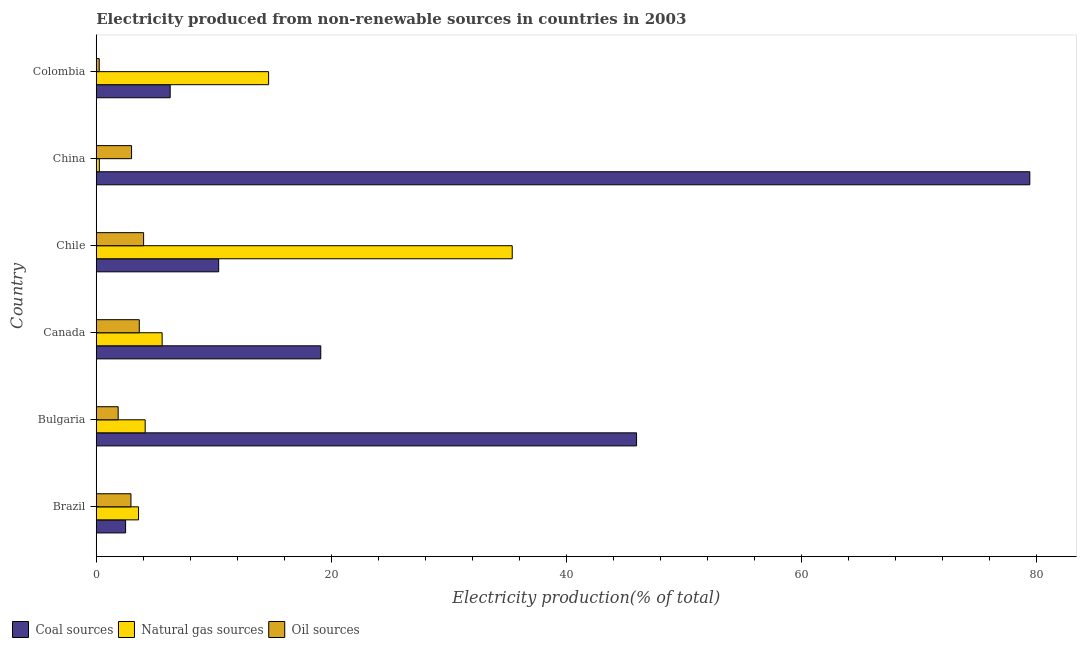How many groups of bars are there?
Offer a terse response. 6. Are the number of bars per tick equal to the number of legend labels?
Offer a terse response. Yes. What is the percentage of electricity produced by coal in Brazil?
Make the answer very short. 2.5. Across all countries, what is the maximum percentage of electricity produced by coal?
Give a very brief answer. 79.44. Across all countries, what is the minimum percentage of electricity produced by coal?
Your response must be concise. 2.5. What is the total percentage of electricity produced by natural gas in the graph?
Offer a terse response. 63.69. What is the difference between the percentage of electricity produced by oil sources in China and that in Colombia?
Offer a very short reply. 2.75. What is the difference between the percentage of electricity produced by natural gas in Bulgaria and the percentage of electricity produced by oil sources in Brazil?
Offer a terse response. 1.21. What is the average percentage of electricity produced by oil sources per country?
Offer a terse response. 2.63. What is the difference between the percentage of electricity produced by natural gas and percentage of electricity produced by coal in Brazil?
Give a very brief answer. 1.1. What is the ratio of the percentage of electricity produced by oil sources in Brazil to that in Canada?
Give a very brief answer. 0.81. Is the difference between the percentage of electricity produced by coal in Canada and Colombia greater than the difference between the percentage of electricity produced by natural gas in Canada and Colombia?
Your response must be concise. Yes. What is the difference between the highest and the second highest percentage of electricity produced by natural gas?
Provide a short and direct response. 20.73. What is the difference between the highest and the lowest percentage of electricity produced by oil sources?
Offer a very short reply. 3.78. In how many countries, is the percentage of electricity produced by oil sources greater than the average percentage of electricity produced by oil sources taken over all countries?
Provide a short and direct response. 4. What does the 1st bar from the top in Chile represents?
Your response must be concise. Oil sources. What does the 1st bar from the bottom in Canada represents?
Give a very brief answer. Coal sources. Is it the case that in every country, the sum of the percentage of electricity produced by coal and percentage of electricity produced by natural gas is greater than the percentage of electricity produced by oil sources?
Provide a succinct answer. Yes. Are all the bars in the graph horizontal?
Ensure brevity in your answer.  Yes. How many countries are there in the graph?
Make the answer very short. 6. Are the values on the major ticks of X-axis written in scientific E-notation?
Your response must be concise. No. Does the graph contain grids?
Provide a succinct answer. No. Where does the legend appear in the graph?
Your answer should be compact. Bottom left. What is the title of the graph?
Provide a succinct answer. Electricity produced from non-renewable sources in countries in 2003. What is the Electricity production(% of total) in Coal sources in Brazil?
Your answer should be compact. 2.5. What is the Electricity production(% of total) in Natural gas sources in Brazil?
Keep it short and to the point. 3.6. What is the Electricity production(% of total) of Oil sources in Brazil?
Ensure brevity in your answer.  2.95. What is the Electricity production(% of total) of Coal sources in Bulgaria?
Ensure brevity in your answer.  45.98. What is the Electricity production(% of total) in Natural gas sources in Bulgaria?
Offer a very short reply. 4.16. What is the Electricity production(% of total) of Oil sources in Bulgaria?
Make the answer very short. 1.86. What is the Electricity production(% of total) of Coal sources in Canada?
Provide a succinct answer. 19.11. What is the Electricity production(% of total) in Natural gas sources in Canada?
Provide a short and direct response. 5.61. What is the Electricity production(% of total) in Oil sources in Canada?
Ensure brevity in your answer.  3.66. What is the Electricity production(% of total) of Coal sources in Chile?
Offer a very short reply. 10.42. What is the Electricity production(% of total) of Natural gas sources in Chile?
Your response must be concise. 35.4. What is the Electricity production(% of total) in Oil sources in Chile?
Offer a terse response. 4.03. What is the Electricity production(% of total) in Coal sources in China?
Keep it short and to the point. 79.44. What is the Electricity production(% of total) of Natural gas sources in China?
Keep it short and to the point. 0.26. What is the Electricity production(% of total) of Oil sources in China?
Keep it short and to the point. 3. What is the Electricity production(% of total) in Coal sources in Colombia?
Provide a short and direct response. 6.29. What is the Electricity production(% of total) of Natural gas sources in Colombia?
Ensure brevity in your answer.  14.67. What is the Electricity production(% of total) of Oil sources in Colombia?
Make the answer very short. 0.25. Across all countries, what is the maximum Electricity production(% of total) in Coal sources?
Make the answer very short. 79.44. Across all countries, what is the maximum Electricity production(% of total) in Natural gas sources?
Give a very brief answer. 35.4. Across all countries, what is the maximum Electricity production(% of total) of Oil sources?
Keep it short and to the point. 4.03. Across all countries, what is the minimum Electricity production(% of total) in Coal sources?
Give a very brief answer. 2.5. Across all countries, what is the minimum Electricity production(% of total) in Natural gas sources?
Your response must be concise. 0.26. Across all countries, what is the minimum Electricity production(% of total) of Oil sources?
Keep it short and to the point. 0.25. What is the total Electricity production(% of total) of Coal sources in the graph?
Your answer should be very brief. 163.73. What is the total Electricity production(% of total) in Natural gas sources in the graph?
Offer a very short reply. 63.69. What is the total Electricity production(% of total) of Oil sources in the graph?
Give a very brief answer. 15.76. What is the difference between the Electricity production(% of total) of Coal sources in Brazil and that in Bulgaria?
Your response must be concise. -43.48. What is the difference between the Electricity production(% of total) of Natural gas sources in Brazil and that in Bulgaria?
Keep it short and to the point. -0.56. What is the difference between the Electricity production(% of total) in Oil sources in Brazil and that in Bulgaria?
Your answer should be very brief. 1.09. What is the difference between the Electricity production(% of total) in Coal sources in Brazil and that in Canada?
Your response must be concise. -16.61. What is the difference between the Electricity production(% of total) in Natural gas sources in Brazil and that in Canada?
Your answer should be very brief. -2.01. What is the difference between the Electricity production(% of total) of Oil sources in Brazil and that in Canada?
Provide a short and direct response. -0.71. What is the difference between the Electricity production(% of total) in Coal sources in Brazil and that in Chile?
Ensure brevity in your answer.  -7.92. What is the difference between the Electricity production(% of total) of Natural gas sources in Brazil and that in Chile?
Give a very brief answer. -31.8. What is the difference between the Electricity production(% of total) of Oil sources in Brazil and that in Chile?
Provide a short and direct response. -1.08. What is the difference between the Electricity production(% of total) of Coal sources in Brazil and that in China?
Provide a succinct answer. -76.95. What is the difference between the Electricity production(% of total) of Natural gas sources in Brazil and that in China?
Provide a short and direct response. 3.34. What is the difference between the Electricity production(% of total) in Oil sources in Brazil and that in China?
Offer a terse response. -0.05. What is the difference between the Electricity production(% of total) of Coal sources in Brazil and that in Colombia?
Provide a short and direct response. -3.8. What is the difference between the Electricity production(% of total) of Natural gas sources in Brazil and that in Colombia?
Give a very brief answer. -11.07. What is the difference between the Electricity production(% of total) in Oil sources in Brazil and that in Colombia?
Offer a terse response. 2.7. What is the difference between the Electricity production(% of total) in Coal sources in Bulgaria and that in Canada?
Offer a terse response. 26.87. What is the difference between the Electricity production(% of total) of Natural gas sources in Bulgaria and that in Canada?
Provide a succinct answer. -1.44. What is the difference between the Electricity production(% of total) of Oil sources in Bulgaria and that in Canada?
Ensure brevity in your answer.  -1.8. What is the difference between the Electricity production(% of total) in Coal sources in Bulgaria and that in Chile?
Offer a terse response. 35.56. What is the difference between the Electricity production(% of total) in Natural gas sources in Bulgaria and that in Chile?
Your answer should be very brief. -31.23. What is the difference between the Electricity production(% of total) in Oil sources in Bulgaria and that in Chile?
Offer a terse response. -2.17. What is the difference between the Electricity production(% of total) in Coal sources in Bulgaria and that in China?
Ensure brevity in your answer.  -33.46. What is the difference between the Electricity production(% of total) in Natural gas sources in Bulgaria and that in China?
Make the answer very short. 3.9. What is the difference between the Electricity production(% of total) in Oil sources in Bulgaria and that in China?
Ensure brevity in your answer.  -1.14. What is the difference between the Electricity production(% of total) of Coal sources in Bulgaria and that in Colombia?
Make the answer very short. 39.69. What is the difference between the Electricity production(% of total) of Natural gas sources in Bulgaria and that in Colombia?
Provide a succinct answer. -10.5. What is the difference between the Electricity production(% of total) in Oil sources in Bulgaria and that in Colombia?
Offer a terse response. 1.61. What is the difference between the Electricity production(% of total) in Coal sources in Canada and that in Chile?
Provide a succinct answer. 8.69. What is the difference between the Electricity production(% of total) in Natural gas sources in Canada and that in Chile?
Your answer should be very brief. -29.79. What is the difference between the Electricity production(% of total) of Oil sources in Canada and that in Chile?
Keep it short and to the point. -0.37. What is the difference between the Electricity production(% of total) in Coal sources in Canada and that in China?
Keep it short and to the point. -60.34. What is the difference between the Electricity production(% of total) in Natural gas sources in Canada and that in China?
Make the answer very short. 5.34. What is the difference between the Electricity production(% of total) in Oil sources in Canada and that in China?
Your answer should be very brief. 0.66. What is the difference between the Electricity production(% of total) of Coal sources in Canada and that in Colombia?
Provide a short and direct response. 12.81. What is the difference between the Electricity production(% of total) in Natural gas sources in Canada and that in Colombia?
Make the answer very short. -9.06. What is the difference between the Electricity production(% of total) of Oil sources in Canada and that in Colombia?
Keep it short and to the point. 3.41. What is the difference between the Electricity production(% of total) of Coal sources in Chile and that in China?
Offer a very short reply. -69.03. What is the difference between the Electricity production(% of total) in Natural gas sources in Chile and that in China?
Offer a very short reply. 35.13. What is the difference between the Electricity production(% of total) in Oil sources in Chile and that in China?
Your response must be concise. 1.03. What is the difference between the Electricity production(% of total) of Coal sources in Chile and that in Colombia?
Provide a short and direct response. 4.13. What is the difference between the Electricity production(% of total) in Natural gas sources in Chile and that in Colombia?
Ensure brevity in your answer.  20.73. What is the difference between the Electricity production(% of total) in Oil sources in Chile and that in Colombia?
Offer a terse response. 3.78. What is the difference between the Electricity production(% of total) of Coal sources in China and that in Colombia?
Ensure brevity in your answer.  73.15. What is the difference between the Electricity production(% of total) in Natural gas sources in China and that in Colombia?
Your answer should be very brief. -14.4. What is the difference between the Electricity production(% of total) in Oil sources in China and that in Colombia?
Your answer should be very brief. 2.75. What is the difference between the Electricity production(% of total) of Coal sources in Brazil and the Electricity production(% of total) of Natural gas sources in Bulgaria?
Offer a very short reply. -1.67. What is the difference between the Electricity production(% of total) of Coal sources in Brazil and the Electricity production(% of total) of Oil sources in Bulgaria?
Keep it short and to the point. 0.63. What is the difference between the Electricity production(% of total) in Natural gas sources in Brazil and the Electricity production(% of total) in Oil sources in Bulgaria?
Provide a short and direct response. 1.73. What is the difference between the Electricity production(% of total) in Coal sources in Brazil and the Electricity production(% of total) in Natural gas sources in Canada?
Ensure brevity in your answer.  -3.11. What is the difference between the Electricity production(% of total) of Coal sources in Brazil and the Electricity production(% of total) of Oil sources in Canada?
Offer a very short reply. -1.17. What is the difference between the Electricity production(% of total) in Natural gas sources in Brazil and the Electricity production(% of total) in Oil sources in Canada?
Your response must be concise. -0.06. What is the difference between the Electricity production(% of total) in Coal sources in Brazil and the Electricity production(% of total) in Natural gas sources in Chile?
Provide a succinct answer. -32.9. What is the difference between the Electricity production(% of total) of Coal sources in Brazil and the Electricity production(% of total) of Oil sources in Chile?
Your response must be concise. -1.53. What is the difference between the Electricity production(% of total) in Natural gas sources in Brazil and the Electricity production(% of total) in Oil sources in Chile?
Give a very brief answer. -0.43. What is the difference between the Electricity production(% of total) in Coal sources in Brazil and the Electricity production(% of total) in Natural gas sources in China?
Provide a succinct answer. 2.23. What is the difference between the Electricity production(% of total) of Coal sources in Brazil and the Electricity production(% of total) of Oil sources in China?
Provide a succinct answer. -0.51. What is the difference between the Electricity production(% of total) in Natural gas sources in Brazil and the Electricity production(% of total) in Oil sources in China?
Keep it short and to the point. 0.59. What is the difference between the Electricity production(% of total) in Coal sources in Brazil and the Electricity production(% of total) in Natural gas sources in Colombia?
Make the answer very short. -12.17. What is the difference between the Electricity production(% of total) in Coal sources in Brazil and the Electricity production(% of total) in Oil sources in Colombia?
Your response must be concise. 2.24. What is the difference between the Electricity production(% of total) of Natural gas sources in Brazil and the Electricity production(% of total) of Oil sources in Colombia?
Offer a terse response. 3.34. What is the difference between the Electricity production(% of total) in Coal sources in Bulgaria and the Electricity production(% of total) in Natural gas sources in Canada?
Your answer should be very brief. 40.37. What is the difference between the Electricity production(% of total) in Coal sources in Bulgaria and the Electricity production(% of total) in Oil sources in Canada?
Your answer should be compact. 42.32. What is the difference between the Electricity production(% of total) in Natural gas sources in Bulgaria and the Electricity production(% of total) in Oil sources in Canada?
Give a very brief answer. 0.5. What is the difference between the Electricity production(% of total) of Coal sources in Bulgaria and the Electricity production(% of total) of Natural gas sources in Chile?
Offer a terse response. 10.58. What is the difference between the Electricity production(% of total) in Coal sources in Bulgaria and the Electricity production(% of total) in Oil sources in Chile?
Your answer should be compact. 41.95. What is the difference between the Electricity production(% of total) of Natural gas sources in Bulgaria and the Electricity production(% of total) of Oil sources in Chile?
Your answer should be compact. 0.13. What is the difference between the Electricity production(% of total) of Coal sources in Bulgaria and the Electricity production(% of total) of Natural gas sources in China?
Ensure brevity in your answer.  45.72. What is the difference between the Electricity production(% of total) of Coal sources in Bulgaria and the Electricity production(% of total) of Oil sources in China?
Your response must be concise. 42.98. What is the difference between the Electricity production(% of total) in Natural gas sources in Bulgaria and the Electricity production(% of total) in Oil sources in China?
Give a very brief answer. 1.16. What is the difference between the Electricity production(% of total) in Coal sources in Bulgaria and the Electricity production(% of total) in Natural gas sources in Colombia?
Make the answer very short. 31.31. What is the difference between the Electricity production(% of total) in Coal sources in Bulgaria and the Electricity production(% of total) in Oil sources in Colombia?
Keep it short and to the point. 45.73. What is the difference between the Electricity production(% of total) in Natural gas sources in Bulgaria and the Electricity production(% of total) in Oil sources in Colombia?
Provide a succinct answer. 3.91. What is the difference between the Electricity production(% of total) of Coal sources in Canada and the Electricity production(% of total) of Natural gas sources in Chile?
Make the answer very short. -16.29. What is the difference between the Electricity production(% of total) of Coal sources in Canada and the Electricity production(% of total) of Oil sources in Chile?
Provide a short and direct response. 15.08. What is the difference between the Electricity production(% of total) of Natural gas sources in Canada and the Electricity production(% of total) of Oil sources in Chile?
Offer a very short reply. 1.58. What is the difference between the Electricity production(% of total) of Coal sources in Canada and the Electricity production(% of total) of Natural gas sources in China?
Provide a succinct answer. 18.84. What is the difference between the Electricity production(% of total) in Coal sources in Canada and the Electricity production(% of total) in Oil sources in China?
Give a very brief answer. 16.1. What is the difference between the Electricity production(% of total) in Natural gas sources in Canada and the Electricity production(% of total) in Oil sources in China?
Your answer should be compact. 2.6. What is the difference between the Electricity production(% of total) in Coal sources in Canada and the Electricity production(% of total) in Natural gas sources in Colombia?
Provide a succinct answer. 4.44. What is the difference between the Electricity production(% of total) of Coal sources in Canada and the Electricity production(% of total) of Oil sources in Colombia?
Your answer should be compact. 18.85. What is the difference between the Electricity production(% of total) of Natural gas sources in Canada and the Electricity production(% of total) of Oil sources in Colombia?
Ensure brevity in your answer.  5.35. What is the difference between the Electricity production(% of total) of Coal sources in Chile and the Electricity production(% of total) of Natural gas sources in China?
Keep it short and to the point. 10.15. What is the difference between the Electricity production(% of total) of Coal sources in Chile and the Electricity production(% of total) of Oil sources in China?
Keep it short and to the point. 7.41. What is the difference between the Electricity production(% of total) of Natural gas sources in Chile and the Electricity production(% of total) of Oil sources in China?
Your answer should be compact. 32.39. What is the difference between the Electricity production(% of total) in Coal sources in Chile and the Electricity production(% of total) in Natural gas sources in Colombia?
Offer a terse response. -4.25. What is the difference between the Electricity production(% of total) of Coal sources in Chile and the Electricity production(% of total) of Oil sources in Colombia?
Give a very brief answer. 10.16. What is the difference between the Electricity production(% of total) in Natural gas sources in Chile and the Electricity production(% of total) in Oil sources in Colombia?
Provide a short and direct response. 35.14. What is the difference between the Electricity production(% of total) of Coal sources in China and the Electricity production(% of total) of Natural gas sources in Colombia?
Give a very brief answer. 64.78. What is the difference between the Electricity production(% of total) in Coal sources in China and the Electricity production(% of total) in Oil sources in Colombia?
Make the answer very short. 79.19. What is the difference between the Electricity production(% of total) of Natural gas sources in China and the Electricity production(% of total) of Oil sources in Colombia?
Make the answer very short. 0.01. What is the average Electricity production(% of total) in Coal sources per country?
Give a very brief answer. 27.29. What is the average Electricity production(% of total) of Natural gas sources per country?
Keep it short and to the point. 10.62. What is the average Electricity production(% of total) of Oil sources per country?
Ensure brevity in your answer.  2.63. What is the difference between the Electricity production(% of total) in Coal sources and Electricity production(% of total) in Natural gas sources in Brazil?
Your answer should be very brief. -1.1. What is the difference between the Electricity production(% of total) of Coal sources and Electricity production(% of total) of Oil sources in Brazil?
Offer a very short reply. -0.46. What is the difference between the Electricity production(% of total) of Natural gas sources and Electricity production(% of total) of Oil sources in Brazil?
Offer a terse response. 0.65. What is the difference between the Electricity production(% of total) of Coal sources and Electricity production(% of total) of Natural gas sources in Bulgaria?
Your answer should be very brief. 41.82. What is the difference between the Electricity production(% of total) in Coal sources and Electricity production(% of total) in Oil sources in Bulgaria?
Give a very brief answer. 44.12. What is the difference between the Electricity production(% of total) in Natural gas sources and Electricity production(% of total) in Oil sources in Bulgaria?
Keep it short and to the point. 2.3. What is the difference between the Electricity production(% of total) of Coal sources and Electricity production(% of total) of Natural gas sources in Canada?
Your answer should be very brief. 13.5. What is the difference between the Electricity production(% of total) in Coal sources and Electricity production(% of total) in Oil sources in Canada?
Give a very brief answer. 15.44. What is the difference between the Electricity production(% of total) in Natural gas sources and Electricity production(% of total) in Oil sources in Canada?
Your answer should be very brief. 1.95. What is the difference between the Electricity production(% of total) in Coal sources and Electricity production(% of total) in Natural gas sources in Chile?
Your response must be concise. -24.98. What is the difference between the Electricity production(% of total) in Coal sources and Electricity production(% of total) in Oil sources in Chile?
Provide a succinct answer. 6.39. What is the difference between the Electricity production(% of total) in Natural gas sources and Electricity production(% of total) in Oil sources in Chile?
Your answer should be very brief. 31.37. What is the difference between the Electricity production(% of total) in Coal sources and Electricity production(% of total) in Natural gas sources in China?
Offer a terse response. 79.18. What is the difference between the Electricity production(% of total) in Coal sources and Electricity production(% of total) in Oil sources in China?
Make the answer very short. 76.44. What is the difference between the Electricity production(% of total) of Natural gas sources and Electricity production(% of total) of Oil sources in China?
Ensure brevity in your answer.  -2.74. What is the difference between the Electricity production(% of total) of Coal sources and Electricity production(% of total) of Natural gas sources in Colombia?
Offer a very short reply. -8.38. What is the difference between the Electricity production(% of total) of Coal sources and Electricity production(% of total) of Oil sources in Colombia?
Provide a short and direct response. 6.04. What is the difference between the Electricity production(% of total) in Natural gas sources and Electricity production(% of total) in Oil sources in Colombia?
Give a very brief answer. 14.41. What is the ratio of the Electricity production(% of total) in Coal sources in Brazil to that in Bulgaria?
Offer a terse response. 0.05. What is the ratio of the Electricity production(% of total) of Natural gas sources in Brazil to that in Bulgaria?
Your response must be concise. 0.86. What is the ratio of the Electricity production(% of total) in Oil sources in Brazil to that in Bulgaria?
Offer a very short reply. 1.58. What is the ratio of the Electricity production(% of total) in Coal sources in Brazil to that in Canada?
Provide a short and direct response. 0.13. What is the ratio of the Electricity production(% of total) in Natural gas sources in Brazil to that in Canada?
Make the answer very short. 0.64. What is the ratio of the Electricity production(% of total) in Oil sources in Brazil to that in Canada?
Your answer should be compact. 0.81. What is the ratio of the Electricity production(% of total) in Coal sources in Brazil to that in Chile?
Your answer should be very brief. 0.24. What is the ratio of the Electricity production(% of total) in Natural gas sources in Brazil to that in Chile?
Your answer should be compact. 0.1. What is the ratio of the Electricity production(% of total) in Oil sources in Brazil to that in Chile?
Provide a succinct answer. 0.73. What is the ratio of the Electricity production(% of total) in Coal sources in Brazil to that in China?
Offer a terse response. 0.03. What is the ratio of the Electricity production(% of total) of Natural gas sources in Brazil to that in China?
Your answer should be very brief. 13.72. What is the ratio of the Electricity production(% of total) in Oil sources in Brazil to that in China?
Your answer should be very brief. 0.98. What is the ratio of the Electricity production(% of total) of Coal sources in Brazil to that in Colombia?
Ensure brevity in your answer.  0.4. What is the ratio of the Electricity production(% of total) in Natural gas sources in Brazil to that in Colombia?
Make the answer very short. 0.25. What is the ratio of the Electricity production(% of total) of Oil sources in Brazil to that in Colombia?
Your response must be concise. 11.64. What is the ratio of the Electricity production(% of total) of Coal sources in Bulgaria to that in Canada?
Keep it short and to the point. 2.41. What is the ratio of the Electricity production(% of total) of Natural gas sources in Bulgaria to that in Canada?
Provide a short and direct response. 0.74. What is the ratio of the Electricity production(% of total) of Oil sources in Bulgaria to that in Canada?
Ensure brevity in your answer.  0.51. What is the ratio of the Electricity production(% of total) of Coal sources in Bulgaria to that in Chile?
Offer a terse response. 4.41. What is the ratio of the Electricity production(% of total) of Natural gas sources in Bulgaria to that in Chile?
Offer a terse response. 0.12. What is the ratio of the Electricity production(% of total) of Oil sources in Bulgaria to that in Chile?
Your answer should be compact. 0.46. What is the ratio of the Electricity production(% of total) in Coal sources in Bulgaria to that in China?
Provide a succinct answer. 0.58. What is the ratio of the Electricity production(% of total) in Natural gas sources in Bulgaria to that in China?
Ensure brevity in your answer.  15.88. What is the ratio of the Electricity production(% of total) of Oil sources in Bulgaria to that in China?
Provide a succinct answer. 0.62. What is the ratio of the Electricity production(% of total) of Coal sources in Bulgaria to that in Colombia?
Offer a terse response. 7.31. What is the ratio of the Electricity production(% of total) in Natural gas sources in Bulgaria to that in Colombia?
Give a very brief answer. 0.28. What is the ratio of the Electricity production(% of total) of Oil sources in Bulgaria to that in Colombia?
Offer a terse response. 7.35. What is the ratio of the Electricity production(% of total) in Coal sources in Canada to that in Chile?
Offer a very short reply. 1.83. What is the ratio of the Electricity production(% of total) in Natural gas sources in Canada to that in Chile?
Your answer should be very brief. 0.16. What is the ratio of the Electricity production(% of total) in Oil sources in Canada to that in Chile?
Your response must be concise. 0.91. What is the ratio of the Electricity production(% of total) in Coal sources in Canada to that in China?
Offer a very short reply. 0.24. What is the ratio of the Electricity production(% of total) in Natural gas sources in Canada to that in China?
Your answer should be very brief. 21.38. What is the ratio of the Electricity production(% of total) in Oil sources in Canada to that in China?
Your answer should be compact. 1.22. What is the ratio of the Electricity production(% of total) in Coal sources in Canada to that in Colombia?
Make the answer very short. 3.04. What is the ratio of the Electricity production(% of total) of Natural gas sources in Canada to that in Colombia?
Your answer should be very brief. 0.38. What is the ratio of the Electricity production(% of total) in Oil sources in Canada to that in Colombia?
Ensure brevity in your answer.  14.44. What is the ratio of the Electricity production(% of total) of Coal sources in Chile to that in China?
Offer a very short reply. 0.13. What is the ratio of the Electricity production(% of total) of Natural gas sources in Chile to that in China?
Give a very brief answer. 135.01. What is the ratio of the Electricity production(% of total) of Oil sources in Chile to that in China?
Your response must be concise. 1.34. What is the ratio of the Electricity production(% of total) in Coal sources in Chile to that in Colombia?
Your response must be concise. 1.66. What is the ratio of the Electricity production(% of total) of Natural gas sources in Chile to that in Colombia?
Your response must be concise. 2.41. What is the ratio of the Electricity production(% of total) of Oil sources in Chile to that in Colombia?
Provide a short and direct response. 15.89. What is the ratio of the Electricity production(% of total) in Coal sources in China to that in Colombia?
Keep it short and to the point. 12.63. What is the ratio of the Electricity production(% of total) of Natural gas sources in China to that in Colombia?
Ensure brevity in your answer.  0.02. What is the ratio of the Electricity production(% of total) in Oil sources in China to that in Colombia?
Give a very brief answer. 11.85. What is the difference between the highest and the second highest Electricity production(% of total) of Coal sources?
Offer a terse response. 33.46. What is the difference between the highest and the second highest Electricity production(% of total) in Natural gas sources?
Your response must be concise. 20.73. What is the difference between the highest and the second highest Electricity production(% of total) of Oil sources?
Your answer should be compact. 0.37. What is the difference between the highest and the lowest Electricity production(% of total) of Coal sources?
Give a very brief answer. 76.95. What is the difference between the highest and the lowest Electricity production(% of total) of Natural gas sources?
Provide a succinct answer. 35.13. What is the difference between the highest and the lowest Electricity production(% of total) of Oil sources?
Offer a terse response. 3.78. 